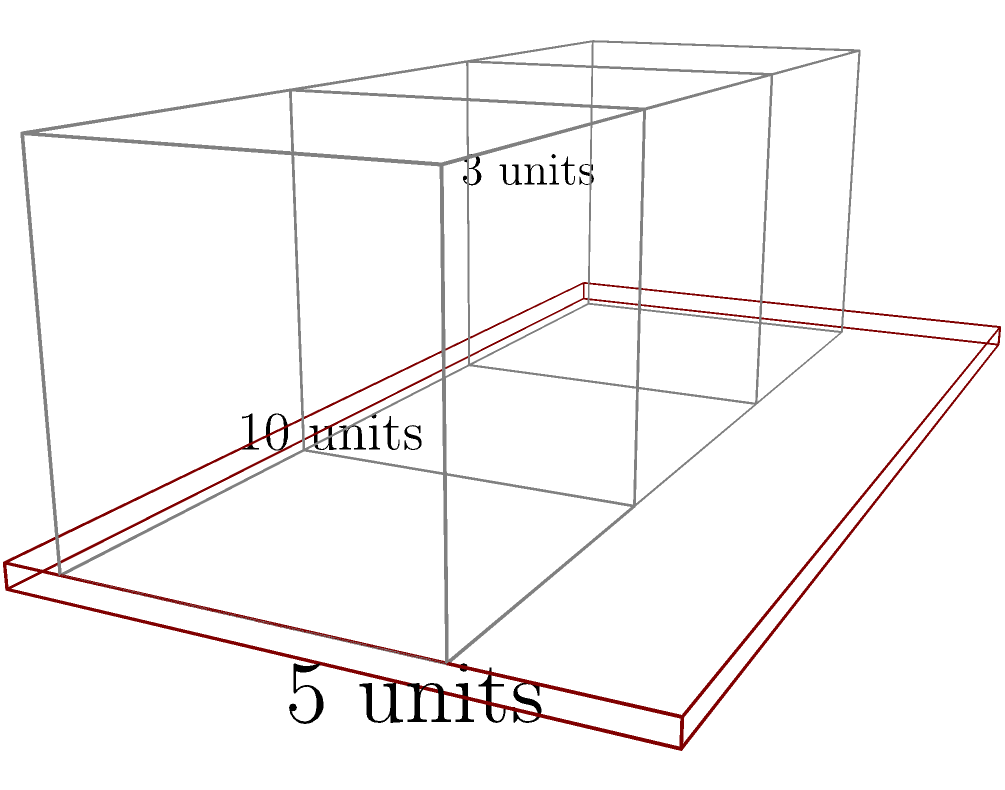A gaming enthusiast wants to set up a triple-monitor battlestation on their desk. The desk measures 10 units long and 5 units deep. Each monitor is 3 units wide and 3 units tall. If the monitors are placed side by side with no gaps between them, what is the maximum viewing distance (in units) from the front edge of the desk that allows the gamer to see all three monitors within a 120° field of view? Let's approach this step-by-step:

1) First, we need to calculate the total width of the three monitors:
   $3 \text{ units} \times 3 = 9 \text{ units}$

2) The monitors will be centered on the desk, leaving 0.5 units on each side:
   $(10 - 9) \div 2 = 0.5 \text{ units}$

3) We can now treat this as a triangle problem. The base of our triangle is the width of the monitors (9 units), and we want to find the height of the triangle (the viewing distance).

4) In a 120° field of view, the angle from the center to each edge is 60°. This forms a 30-60-90 triangle from the center to one edge.

5) In a 30-60-90 triangle, the ratio of sides is 1 : $\sqrt{3}$ : 2

6) Half of our monitor width (4.5 units) represents the longer leg of this triangle (the side opposite to the 60° angle).

7) We can set up the ratio:
   $\frac{\text{viewing distance}}{4.5} = \frac{1}{\sqrt{3}}$

8) Solving for the viewing distance:
   $\text{viewing distance} = \frac{4.5}{\sqrt{3}} \approx 2.60 \text{ units}$

9) This distance is measured from the center of the monitor setup. We need to subtract half the depth of the monitors to get the distance from the front of the desk:
   $2.60 - 1.5 = 1.10 \text{ units}$

Therefore, the maximum viewing distance from the front edge of the desk is approximately 1.10 units.
Answer: 1.10 units 